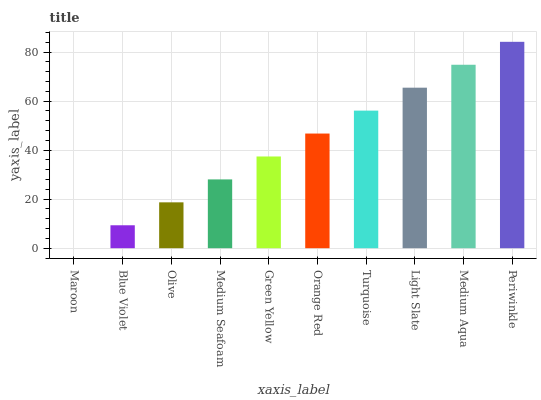Is Blue Violet the minimum?
Answer yes or no. No. Is Blue Violet the maximum?
Answer yes or no. No. Is Blue Violet greater than Maroon?
Answer yes or no. Yes. Is Maroon less than Blue Violet?
Answer yes or no. Yes. Is Maroon greater than Blue Violet?
Answer yes or no. No. Is Blue Violet less than Maroon?
Answer yes or no. No. Is Orange Red the high median?
Answer yes or no. Yes. Is Green Yellow the low median?
Answer yes or no. Yes. Is Medium Seafoam the high median?
Answer yes or no. No. Is Blue Violet the low median?
Answer yes or no. No. 